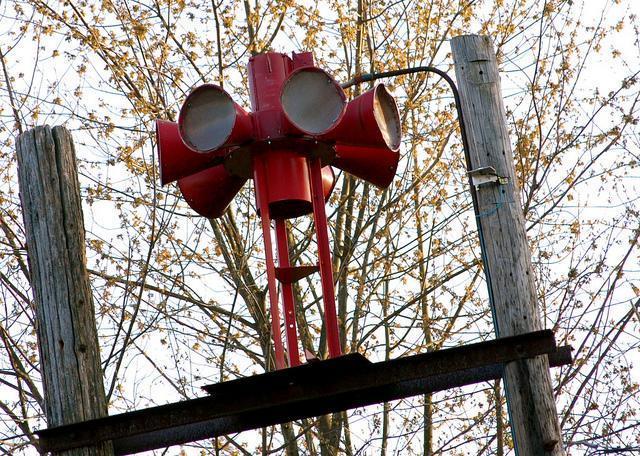How many loudspeakers can be seen?
Give a very brief answer. 7. How many vertical posts are present?
Give a very brief answer. 2. How many traffic lights are visible?
Give a very brief answer. 1. 